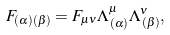Convert formula to latex. <formula><loc_0><loc_0><loc_500><loc_500>F _ { ( \alpha ) ( \beta ) } = F _ { \mu \nu } \Lambda ^ { \mu } _ { \, ( \alpha ) } \Lambda ^ { \nu } _ { \, ( \beta ) } ,</formula> 